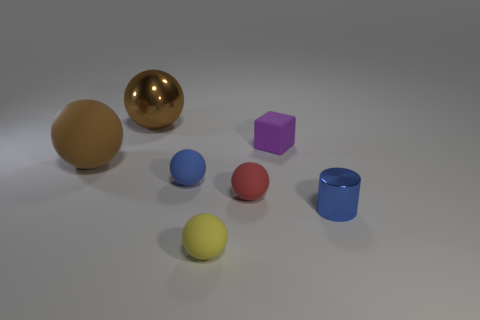How many brown balls must be subtracted to get 1 brown balls? 1 Subtract 1 balls. How many balls are left? 4 Subtract all gray spheres. Subtract all gray blocks. How many spheres are left? 5 Add 2 big cylinders. How many objects exist? 9 Subtract all blocks. How many objects are left? 6 Subtract 1 blue cylinders. How many objects are left? 6 Subtract all large red cubes. Subtract all red spheres. How many objects are left? 6 Add 6 tiny blocks. How many tiny blocks are left? 7 Add 7 small yellow balls. How many small yellow balls exist? 8 